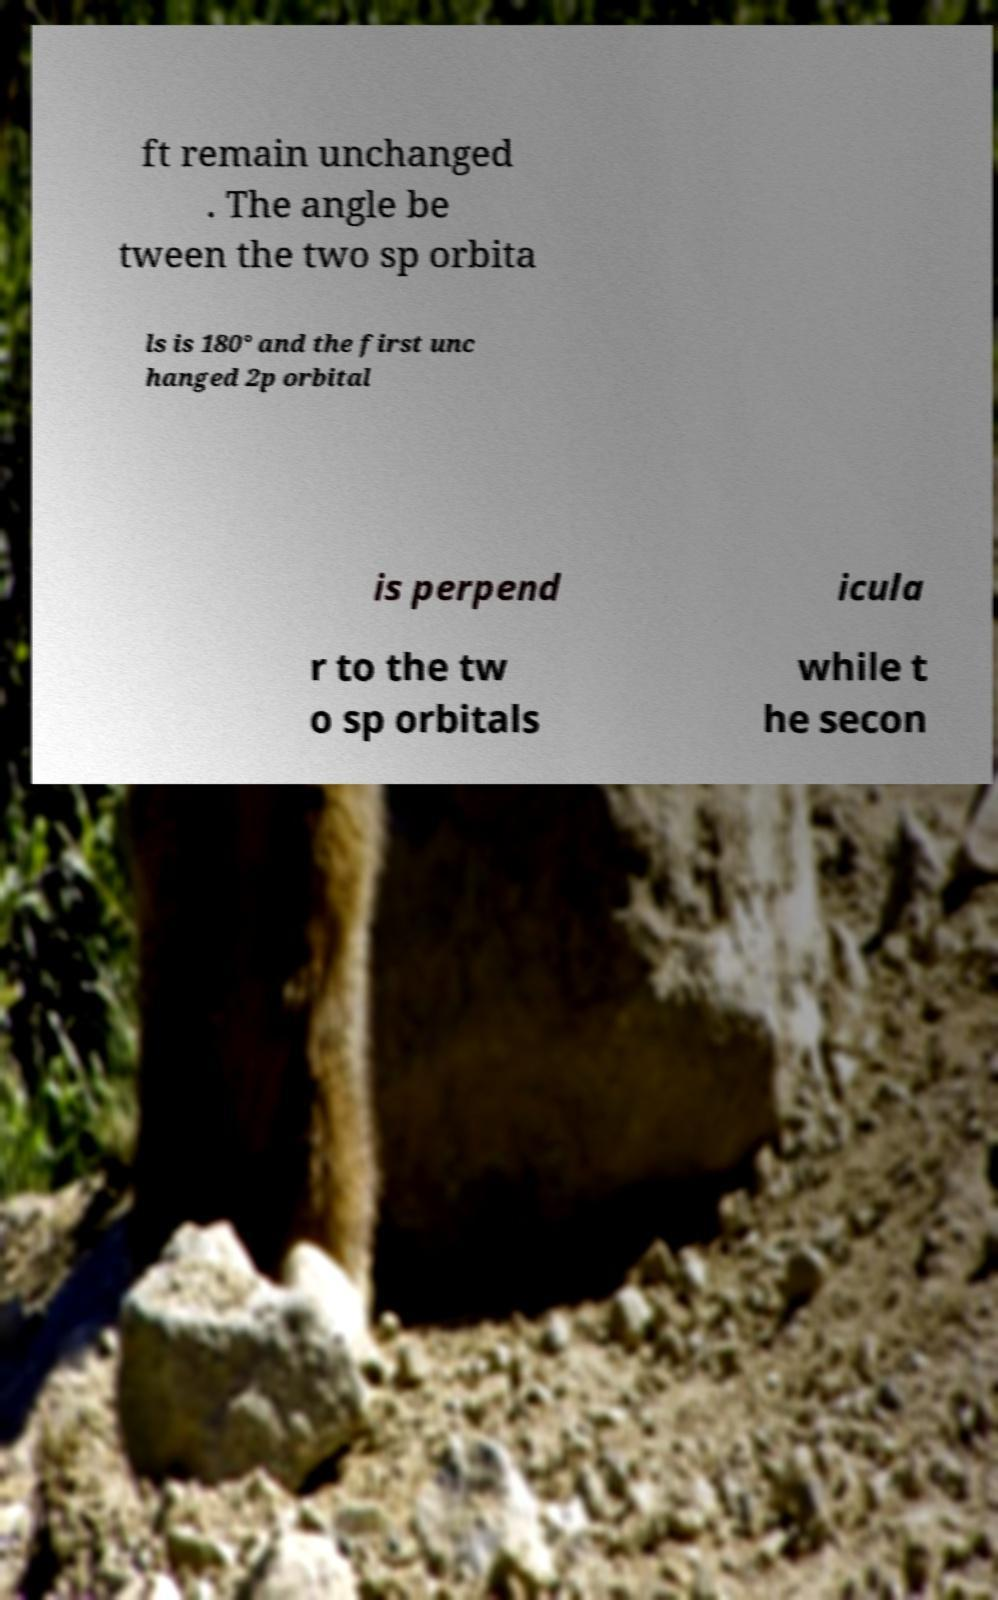Could you extract and type out the text from this image? ft remain unchanged . The angle be tween the two sp orbita ls is 180° and the first unc hanged 2p orbital is perpend icula r to the tw o sp orbitals while t he secon 